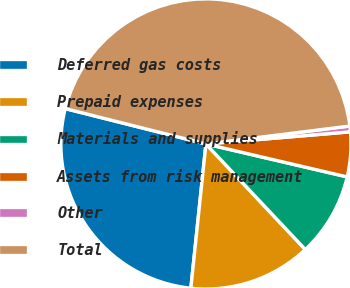Convert chart to OTSL. <chart><loc_0><loc_0><loc_500><loc_500><pie_chart><fcel>Deferred gas costs<fcel>Prepaid expenses<fcel>Materials and supplies<fcel>Assets from risk management<fcel>Other<fcel>Total<nl><fcel>27.26%<fcel>13.68%<fcel>9.33%<fcel>4.98%<fcel>0.64%<fcel>44.11%<nl></chart> 